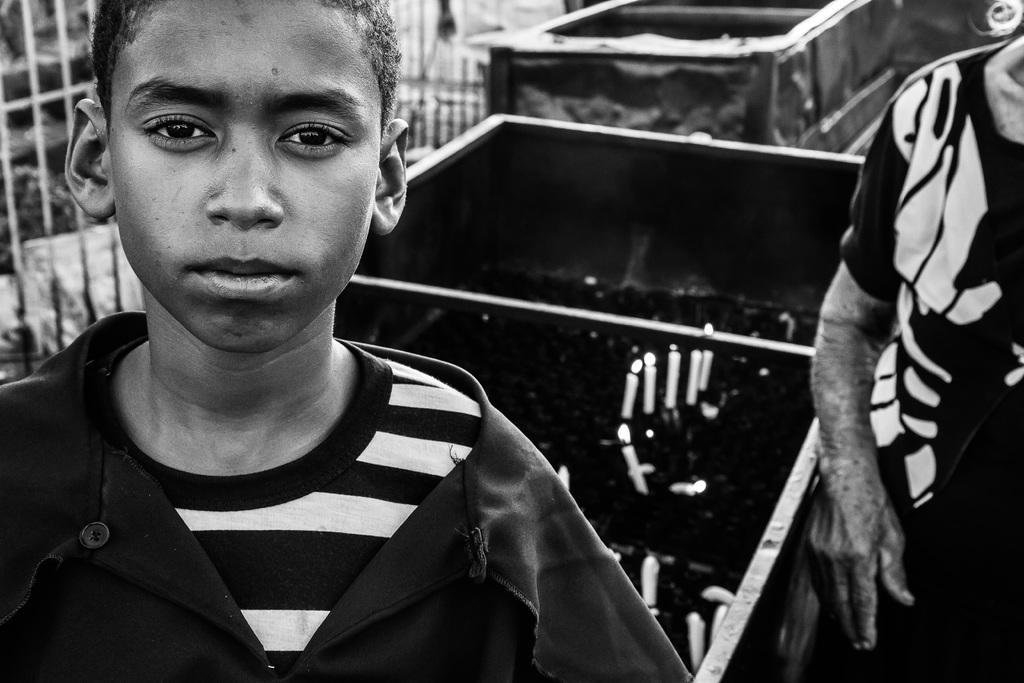Could you give a brief overview of what you see in this image? This is a black and white image. I can see two people standing. I think these are the candles with the flames. These look like the trucks. In the background, I might be a fence. 